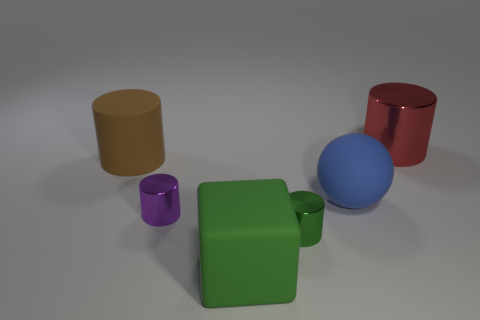Are there any other things that have the same color as the big matte block?
Keep it short and to the point. Yes. There is a big cube; is its color the same as the small metal object that is right of the big green rubber thing?
Give a very brief answer. Yes. How many objects are large rubber objects that are on the right side of the brown matte cylinder or tiny objects?
Your answer should be compact. 4. What material is the large cylinder that is in front of the metal object that is behind the purple cylinder?
Your response must be concise. Rubber. Are there any big things that have the same material as the purple cylinder?
Offer a terse response. Yes. Are there any big blue rubber spheres that are to the right of the matte object right of the small green shiny thing?
Keep it short and to the point. No. What is the large cylinder that is on the right side of the brown cylinder made of?
Keep it short and to the point. Metal. Is the small green metal object the same shape as the large red object?
Provide a short and direct response. Yes. There is a large cylinder left of the red object behind the tiny metal cylinder in front of the small purple metallic thing; what color is it?
Make the answer very short. Brown. How many brown matte objects have the same shape as the small green thing?
Ensure brevity in your answer.  1. 